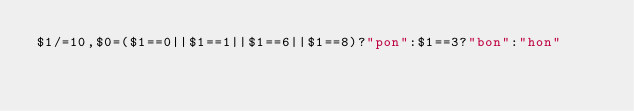Convert code to text. <code><loc_0><loc_0><loc_500><loc_500><_Awk_>$1/=10,$0=($1==0||$1==1||$1==6||$1==8)?"pon":$1==3?"bon":"hon"</code> 